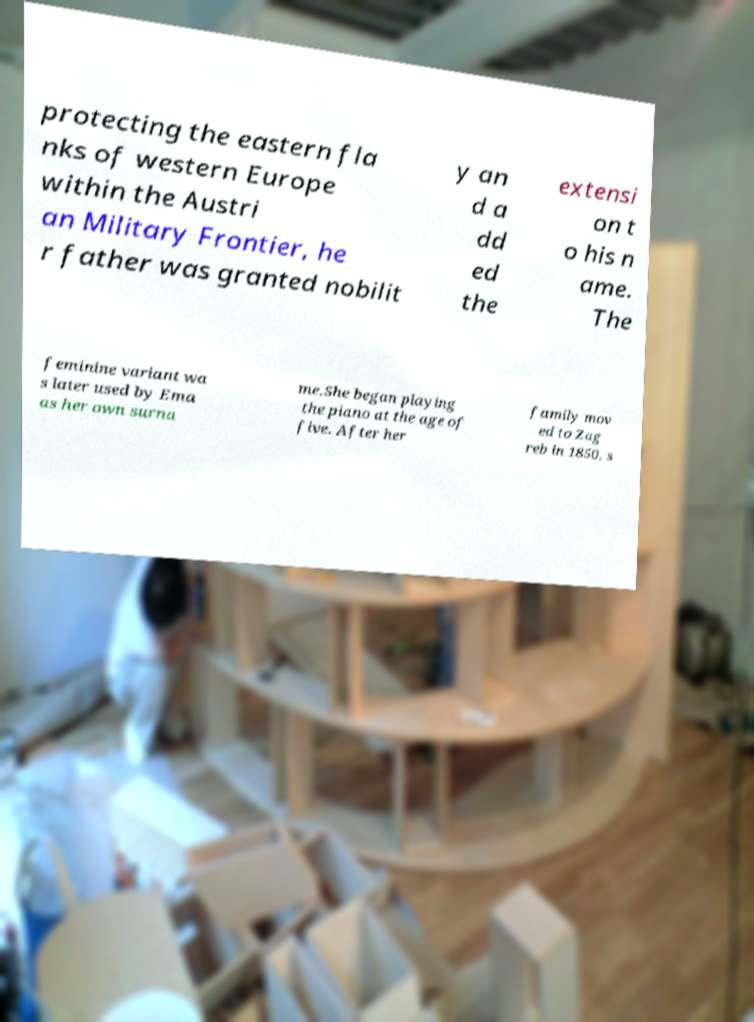There's text embedded in this image that I need extracted. Can you transcribe it verbatim? protecting the eastern fla nks of western Europe within the Austri an Military Frontier, he r father was granted nobilit y an d a dd ed the extensi on t o his n ame. The feminine variant wa s later used by Ema as her own surna me.She began playing the piano at the age of five. After her family mov ed to Zag reb in 1850, s 